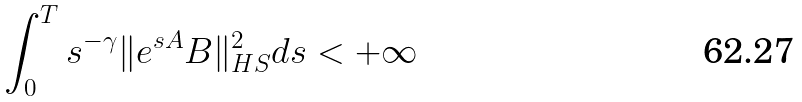<formula> <loc_0><loc_0><loc_500><loc_500>\int _ { 0 } ^ { T } s ^ { - \gamma } \| e ^ { s A } B \| _ { H S } ^ { 2 } d s < + \infty</formula> 